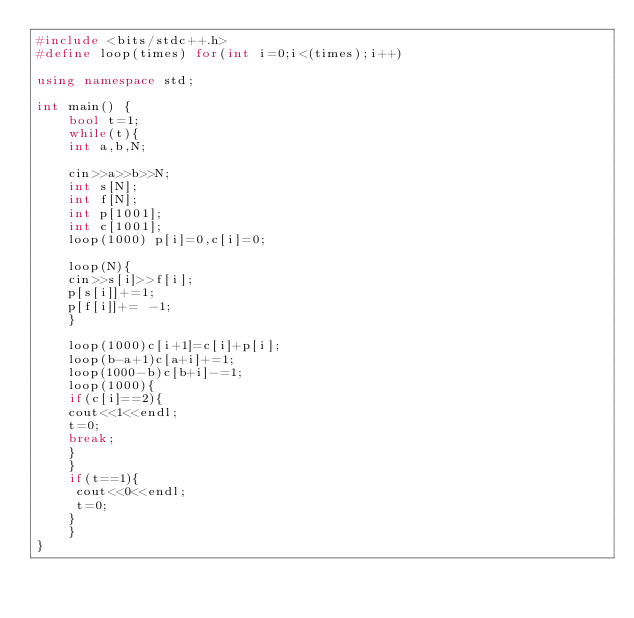<code> <loc_0><loc_0><loc_500><loc_500><_C++_>#include <bits/stdc++.h>
#define loop(times) for(int i=0;i<(times);i++)

using namespace std;

int main() {
    bool t=1;
    while(t){
    int a,b,N;

    cin>>a>>b>>N;
    int s[N];
    int f[N];
    int p[1001];
    int c[1001];
    loop(1000) p[i]=0,c[i]=0;
        
    loop(N){
    cin>>s[i]>>f[i];
    p[s[i]]+=1;
    p[f[i]]+= -1;
    }
        
    loop(1000)c[i+1]=c[i]+p[i];
    loop(b-a+1)c[a+i]+=1;
    loop(1000-b)c[b+i]-=1;
    loop(1000){
    if(c[i]==2){
    cout<<1<<endl;
    t=0;
    break;
    }
    }
    if(t==1){
     cout<<0<<endl;
     t=0;
    }
    }
}
</code> 